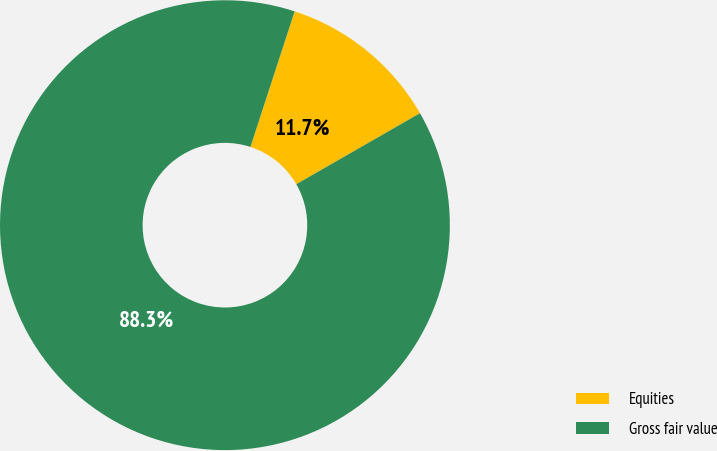Convert chart to OTSL. <chart><loc_0><loc_0><loc_500><loc_500><pie_chart><fcel>Equities<fcel>Gross fair value<nl><fcel>11.69%<fcel>88.31%<nl></chart> 